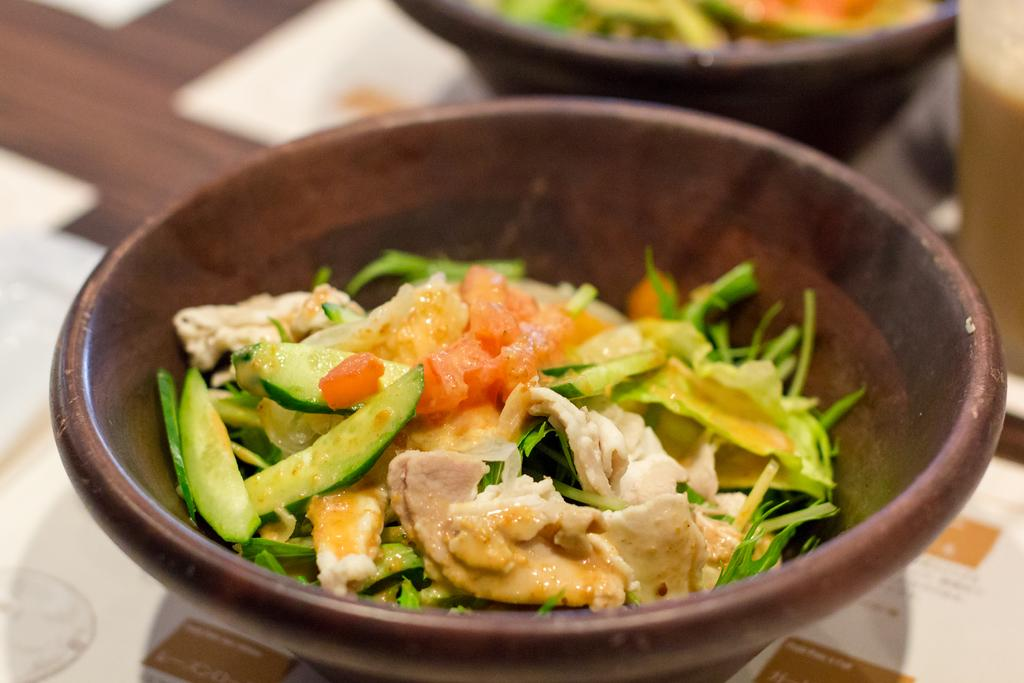What is in the bowl that is visible in the image? There is a food item in the bowl that is visible in the image. Where is the bowl placed in the image? The bowl is placed on a wooden table in the image. Can you describe any other bowls in the image? There is another bowl visible in the background of the image. How would you describe the overall clarity of the image? The background of the image is slightly blurred. What type of tax is being discussed in the image? There is no discussion of tax in the image; it features a bowl with a food item on a wooden table. Is there a tent visible in the image? No, there is no tent present in the image. 